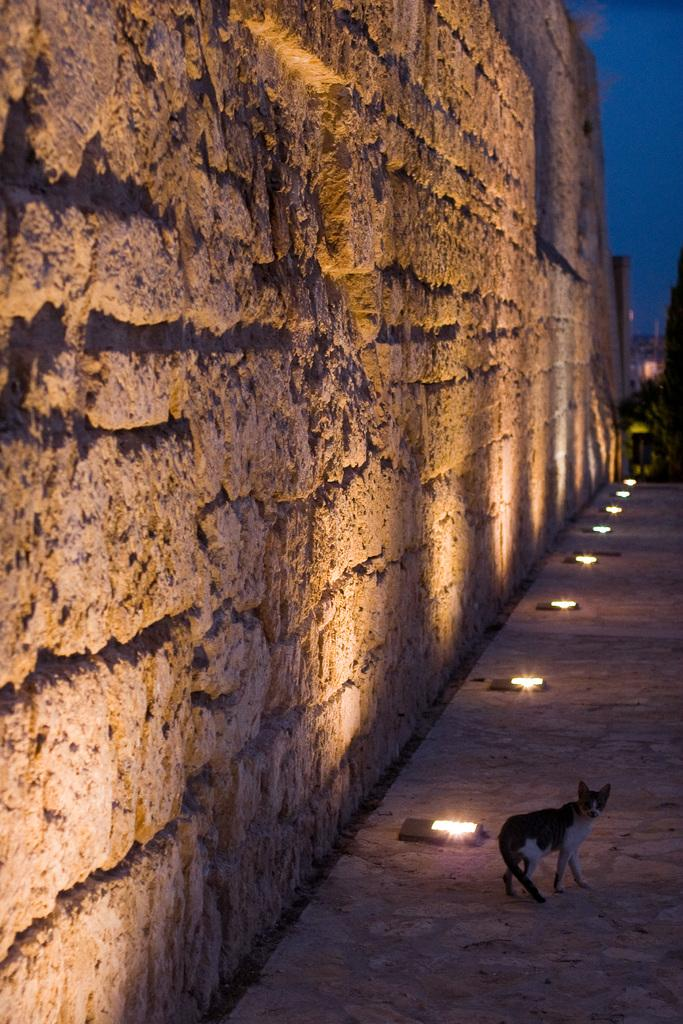What type of animal can be seen on the floor in the image? There is a cat on the floor in the image. What objects are also placed on the floor in the image? There are lamps placed on the floor in the image. What type of wall is present in the image? There is a stone wall in the image. What is the color of the stone wall? The stone wall is brown in color. What can be seen in the background of the image? There is a sky visible in the background of the image. What type of acoustics can be heard in the image? There is no information about acoustics in the image, as it only shows a cat, lamps, a stone wall, and a sky. 